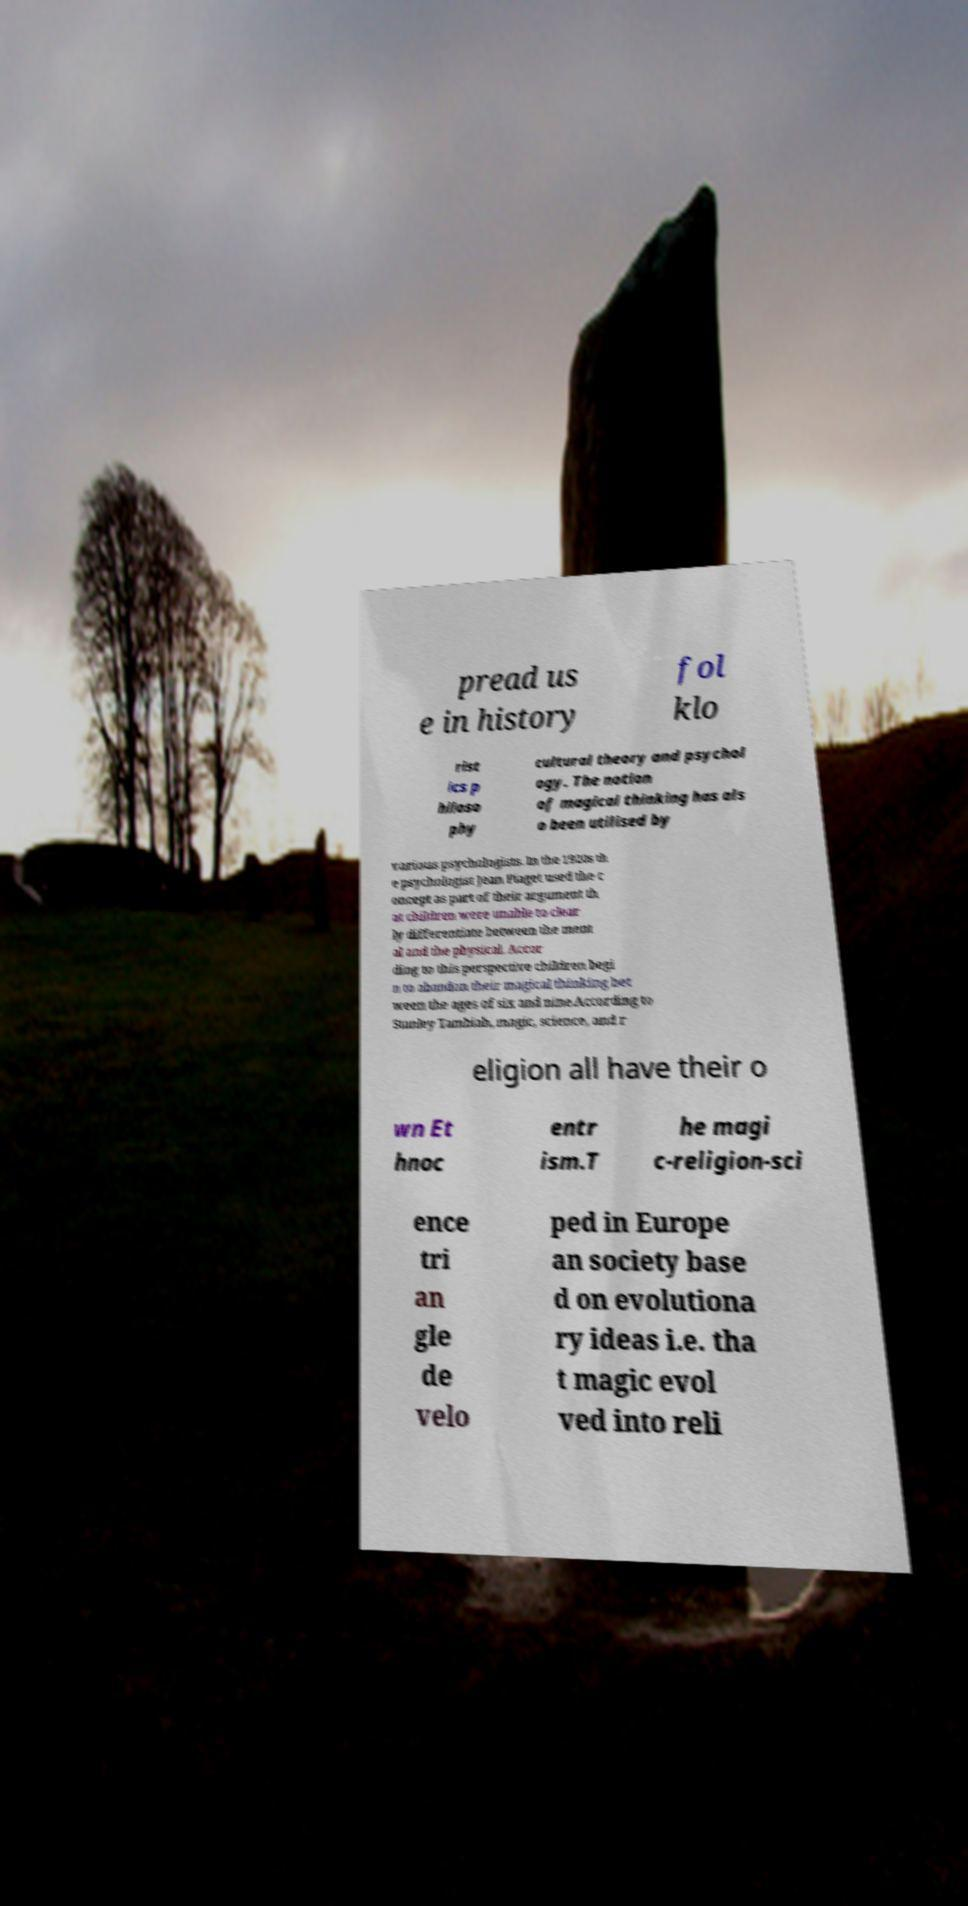Please read and relay the text visible in this image. What does it say? pread us e in history fol klo rist ics p hiloso phy cultural theory and psychol ogy. The notion of magical thinking has als o been utilised by various psychologists. In the 1920s th e psychologist Jean Piaget used the c oncept as part of their argument th at children were unable to clear ly differentiate between the ment al and the physical. Accor ding to this perspective children begi n to abandon their magical thinking bet ween the ages of six and nine.According to Stanley Tambiah, magic, science, and r eligion all have their o wn Et hnoc entr ism.T he magi c-religion-sci ence tri an gle de velo ped in Europe an society base d on evolutiona ry ideas i.e. tha t magic evol ved into reli 